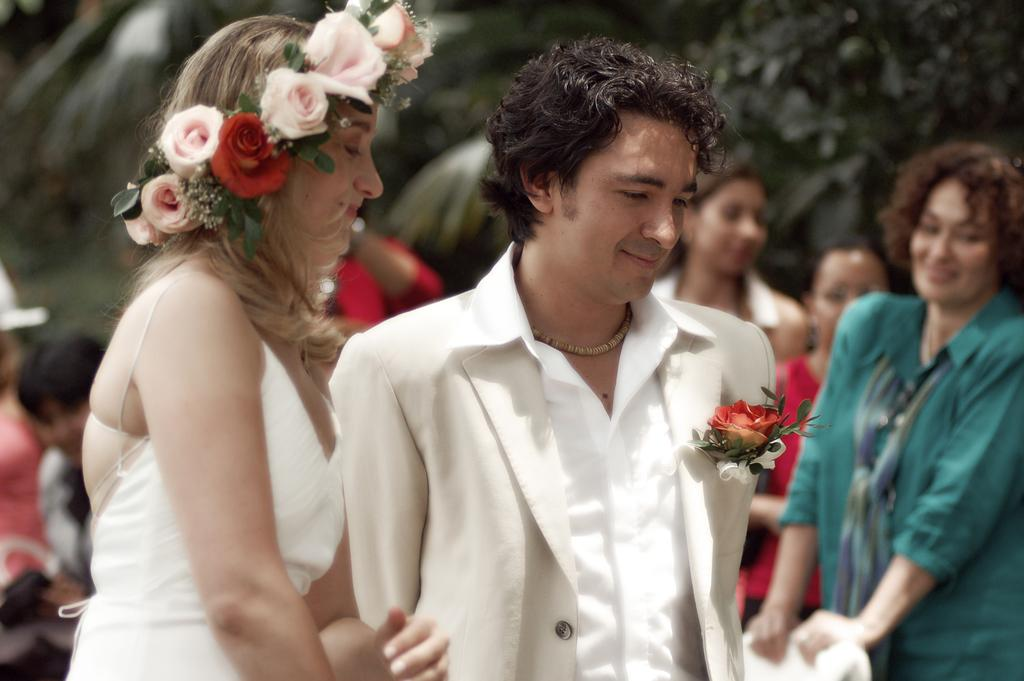How many people are present in the image? There are people in the image, but the exact number is not specified. What is one person doing with an object in the image? One person is holding a chair in the image. What can be seen in the background of the image? There are trees in the background of the image. What type of bell can be heard ringing in the image? There is no bell present or mentioned in the image, so it cannot be heard ringing. 